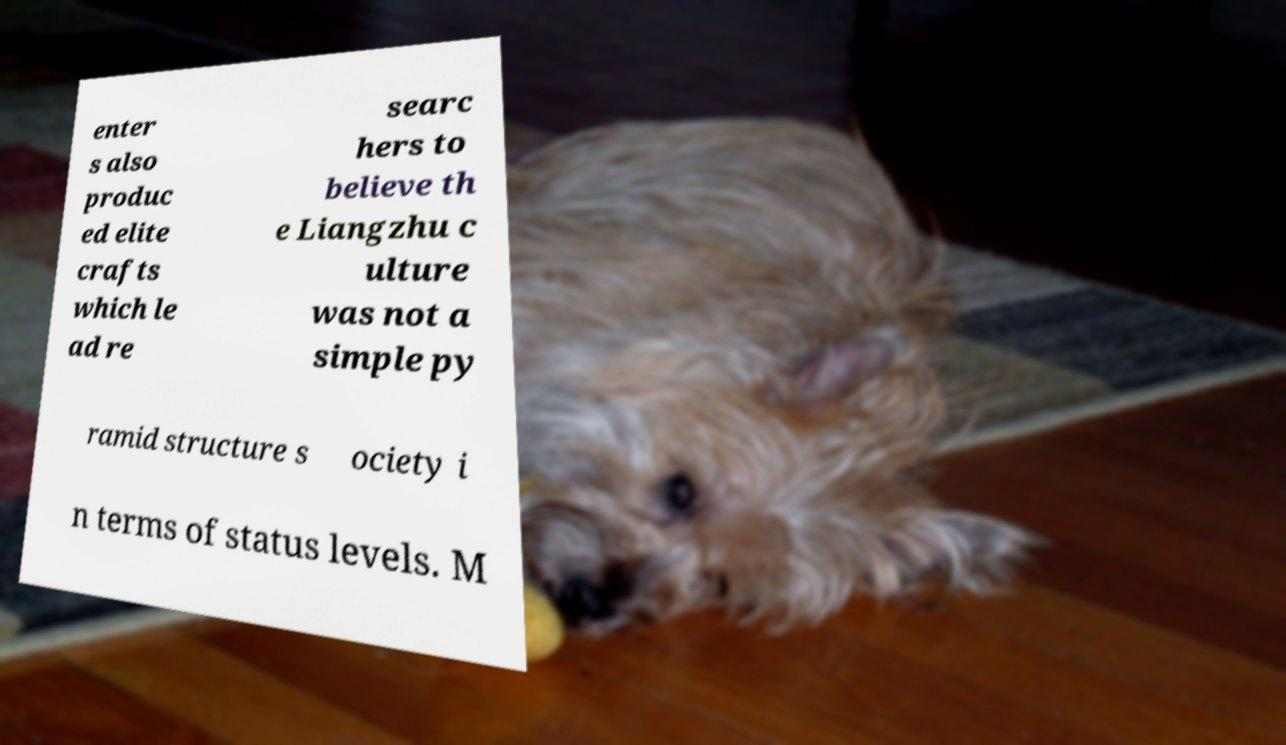Please identify and transcribe the text found in this image. enter s also produc ed elite crafts which le ad re searc hers to believe th e Liangzhu c ulture was not a simple py ramid structure s ociety i n terms of status levels. M 